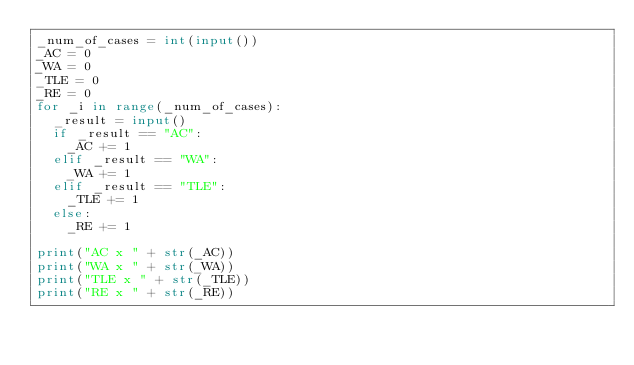Convert code to text. <code><loc_0><loc_0><loc_500><loc_500><_Python_>_num_of_cases = int(input())
_AC = 0
_WA = 0
_TLE = 0
_RE = 0
for _i in range(_num_of_cases):
  _result = input()
  if _result == "AC":
    _AC += 1
  elif _result == "WA":
    _WA += 1
  elif _result == "TLE":
    _TLE += 1
  else:
    _RE += 1

print("AC x " + str(_AC))
print("WA x " + str(_WA))
print("TLE x " + str(_TLE))
print("RE x " + str(_RE))</code> 